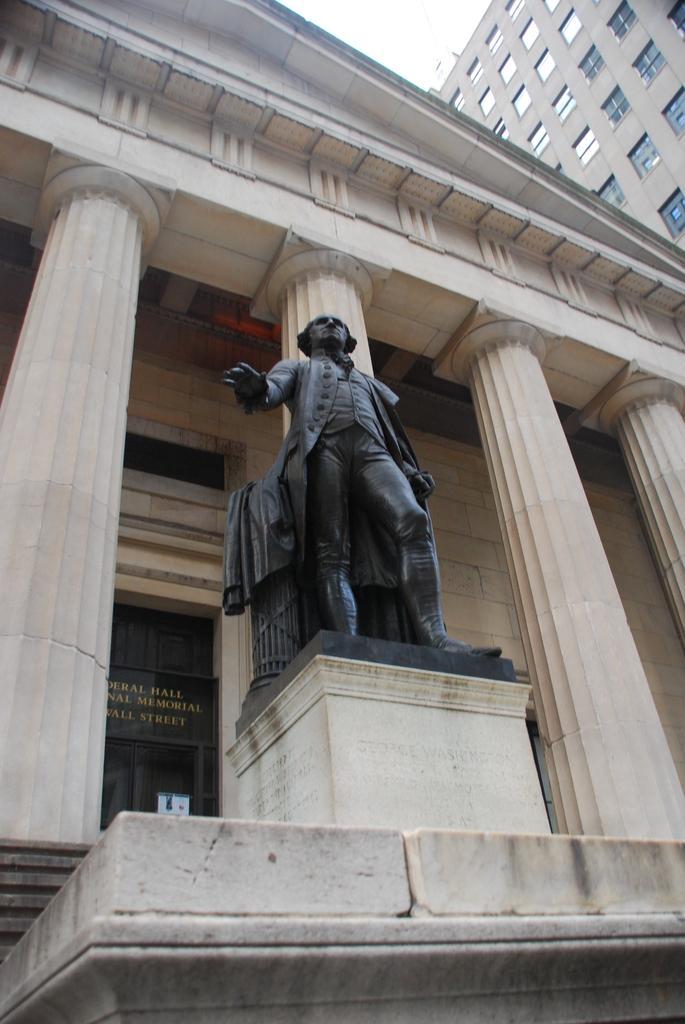Please provide a concise description of this image. In this image I can see a statue of a person. In the background I can see pillars, buildings and the sky. 